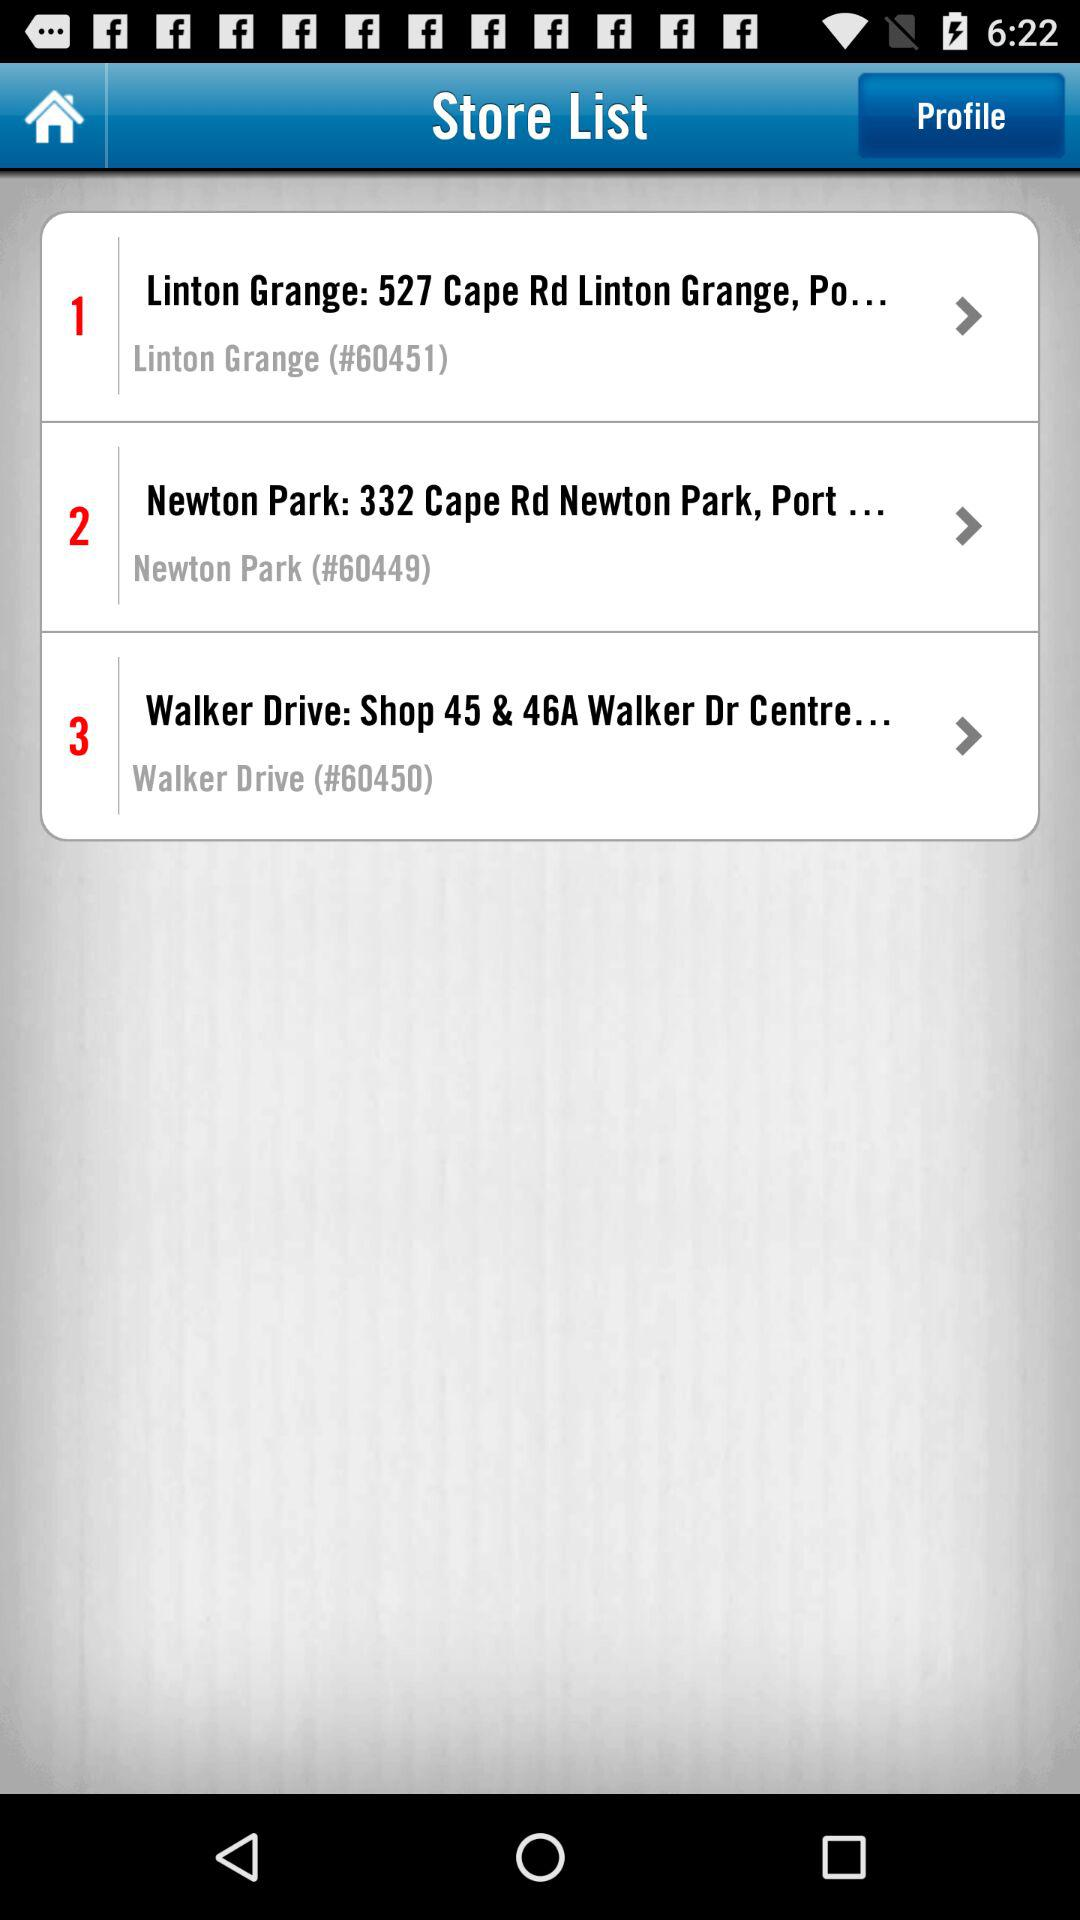What's the Newton Park address? The address is "332 Cape Rd Newton Park, Port...". 